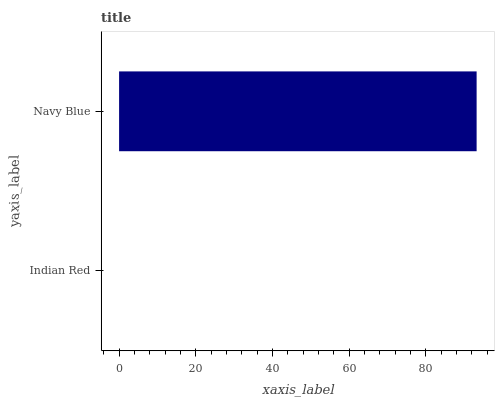Is Indian Red the minimum?
Answer yes or no. Yes. Is Navy Blue the maximum?
Answer yes or no. Yes. Is Navy Blue the minimum?
Answer yes or no. No. Is Navy Blue greater than Indian Red?
Answer yes or no. Yes. Is Indian Red less than Navy Blue?
Answer yes or no. Yes. Is Indian Red greater than Navy Blue?
Answer yes or no. No. Is Navy Blue less than Indian Red?
Answer yes or no. No. Is Navy Blue the high median?
Answer yes or no. Yes. Is Indian Red the low median?
Answer yes or no. Yes. Is Indian Red the high median?
Answer yes or no. No. Is Navy Blue the low median?
Answer yes or no. No. 